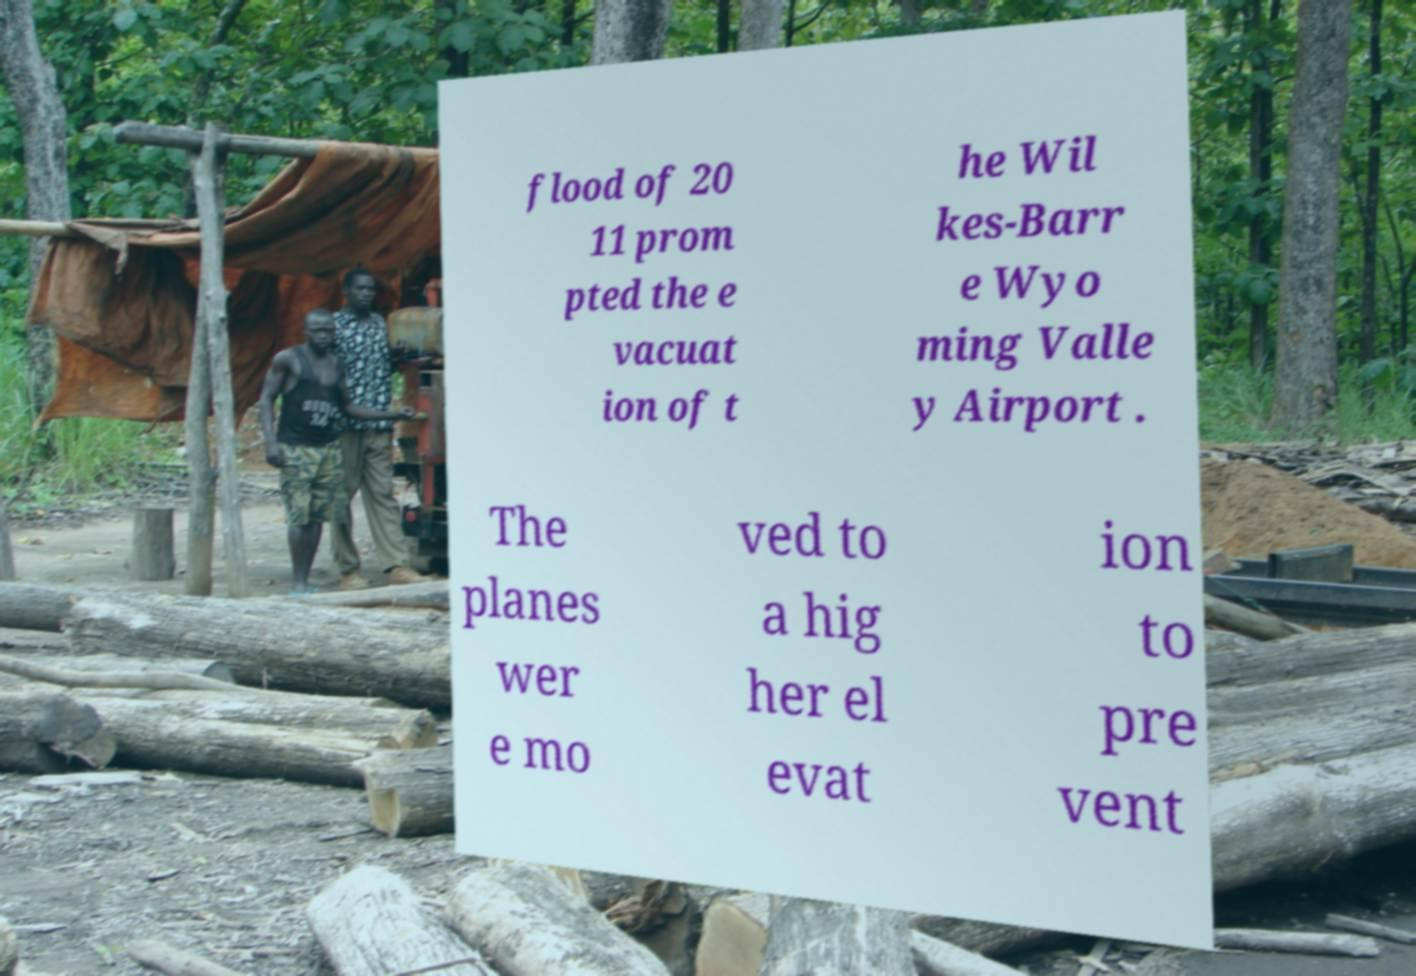Could you extract and type out the text from this image? flood of 20 11 prom pted the e vacuat ion of t he Wil kes-Barr e Wyo ming Valle y Airport . The planes wer e mo ved to a hig her el evat ion to pre vent 